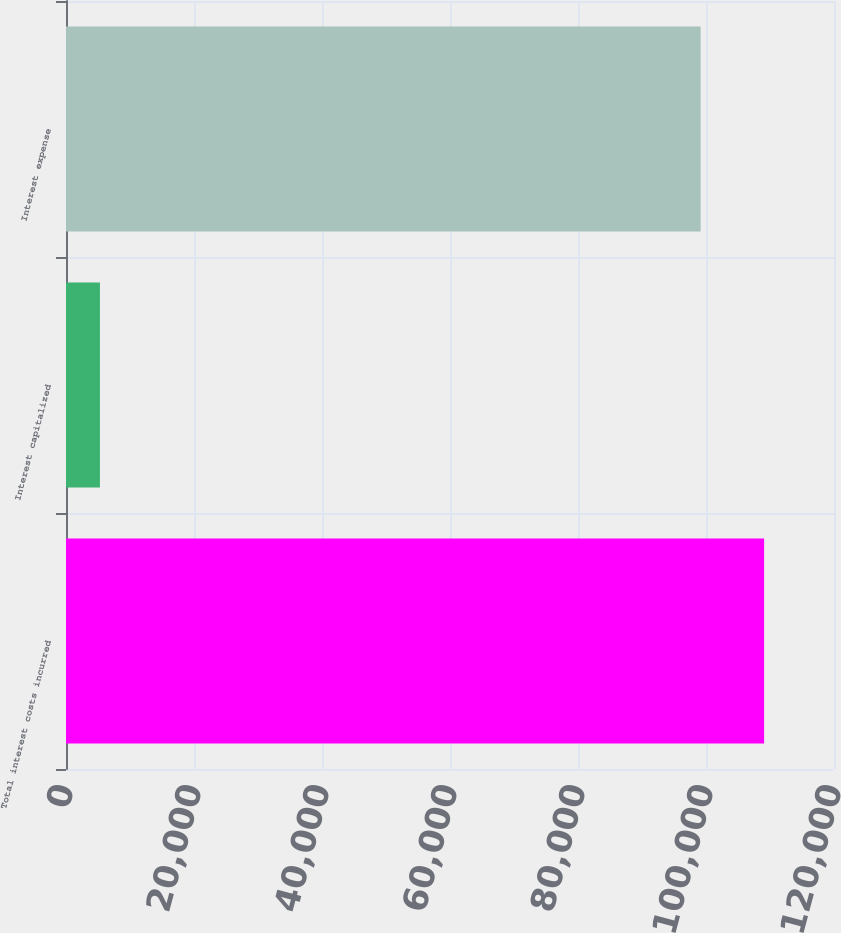Convert chart to OTSL. <chart><loc_0><loc_0><loc_500><loc_500><bar_chart><fcel>Total interest costs incurred<fcel>Interest capitalized<fcel>Interest expense<nl><fcel>109079<fcel>5301<fcel>99163<nl></chart> 